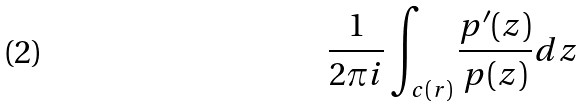<formula> <loc_0><loc_0><loc_500><loc_500>\frac { 1 } { 2 \pi i } \int _ { c ( r ) } \frac { p ^ { \prime } ( z ) } { p ( z ) } d z</formula> 